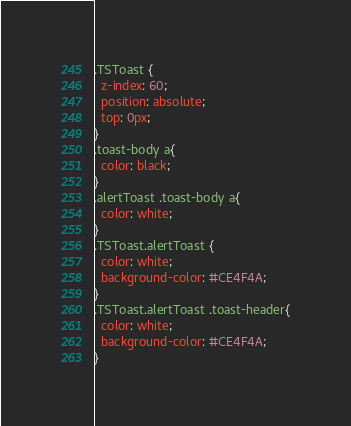<code> <loc_0><loc_0><loc_500><loc_500><_CSS_>.TSToast {
  z-index: 60;
  position: absolute;
  top: 0px;
}
.toast-body a{
  color: black;
}
.alertToast .toast-body a{
  color: white;
}
.TSToast.alertToast {
  color: white;
  background-color: #CE4F4A;
}
.TSToast.alertToast .toast-header{
  color: white;
  background-color: #CE4F4A;
}</code> 